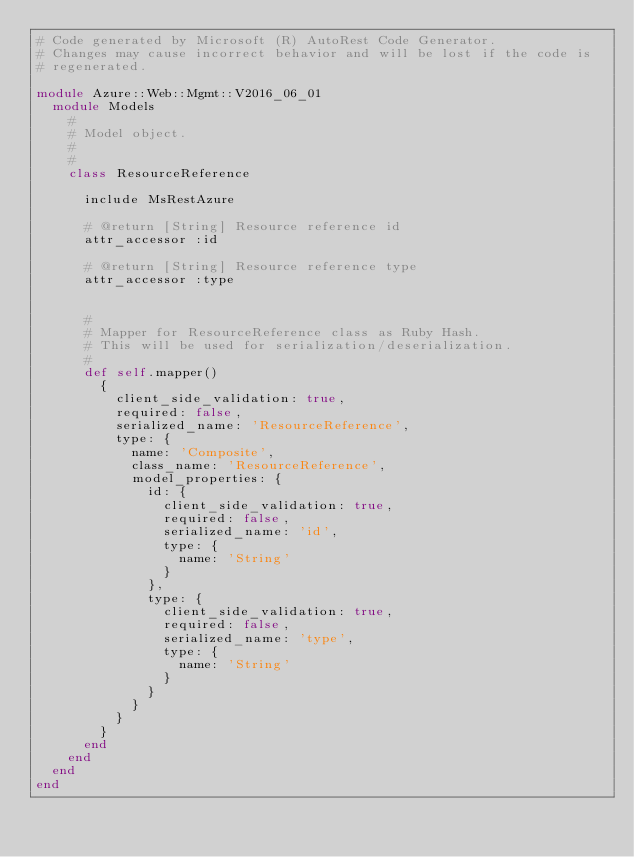Convert code to text. <code><loc_0><loc_0><loc_500><loc_500><_Ruby_># Code generated by Microsoft (R) AutoRest Code Generator.
# Changes may cause incorrect behavior and will be lost if the code is
# regenerated.

module Azure::Web::Mgmt::V2016_06_01
  module Models
    #
    # Model object.
    #
    #
    class ResourceReference

      include MsRestAzure

      # @return [String] Resource reference id
      attr_accessor :id

      # @return [String] Resource reference type
      attr_accessor :type


      #
      # Mapper for ResourceReference class as Ruby Hash.
      # This will be used for serialization/deserialization.
      #
      def self.mapper()
        {
          client_side_validation: true,
          required: false,
          serialized_name: 'ResourceReference',
          type: {
            name: 'Composite',
            class_name: 'ResourceReference',
            model_properties: {
              id: {
                client_side_validation: true,
                required: false,
                serialized_name: 'id',
                type: {
                  name: 'String'
                }
              },
              type: {
                client_side_validation: true,
                required: false,
                serialized_name: 'type',
                type: {
                  name: 'String'
                }
              }
            }
          }
        }
      end
    end
  end
end
</code> 